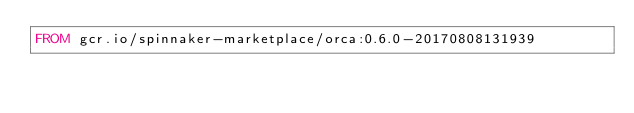<code> <loc_0><loc_0><loc_500><loc_500><_Dockerfile_>FROM gcr.io/spinnaker-marketplace/orca:0.6.0-20170808131939
</code> 